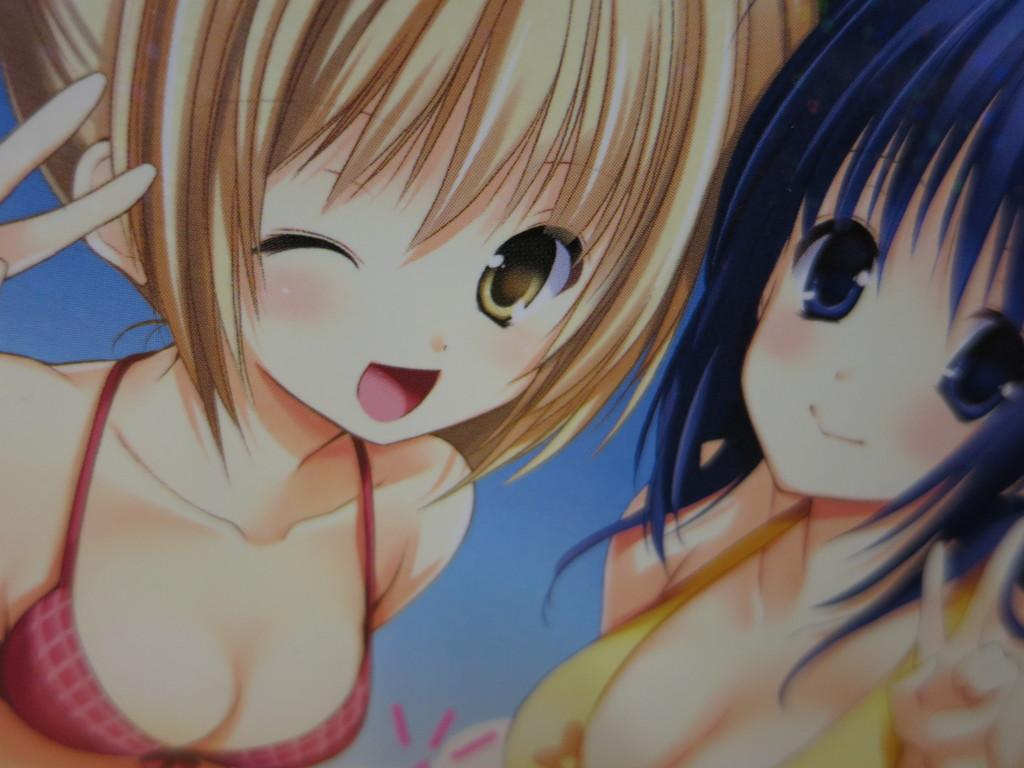What type of image is being described? The image is animated. How many women are present in the image? There are two women in the image. What type of fruit can be seen being juggled by the women in the image? There is no fruit, such as oranges, present in the image, nor are the women juggling anything. Can you recite a verse that is being spoken by the women in the image? There is no dialogue or verse present in the image, as it is an animated image without any spoken words. 